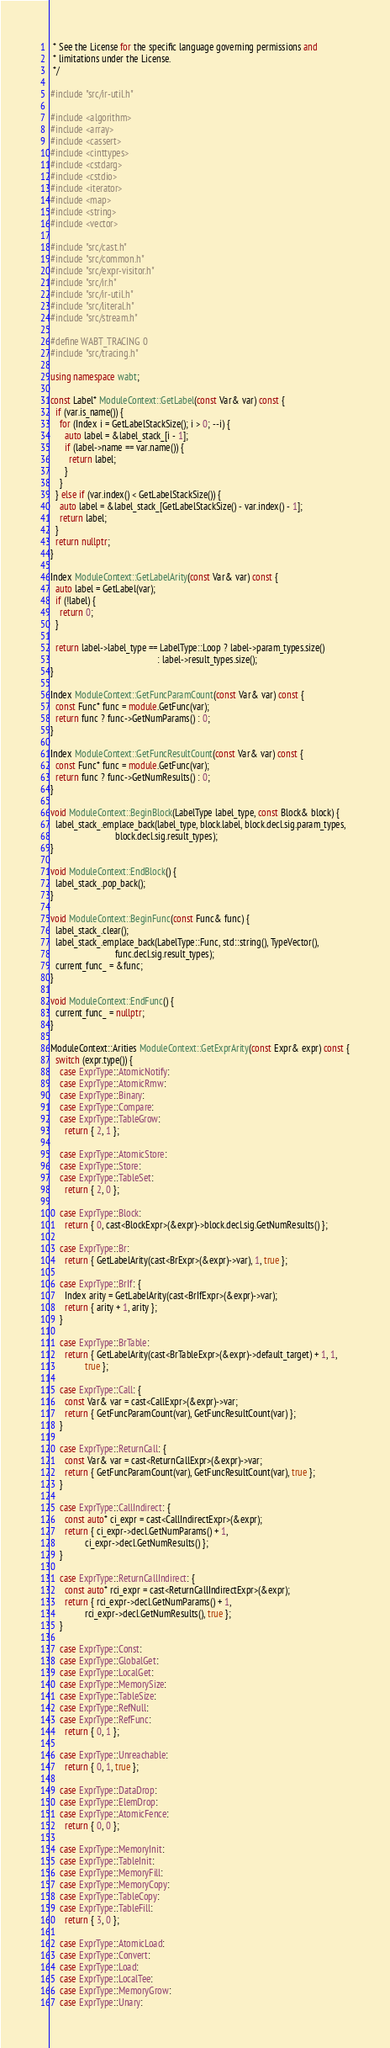Convert code to text. <code><loc_0><loc_0><loc_500><loc_500><_C++_> * See the License for the specific language governing permissions and
 * limitations under the License.
 */

#include "src/ir-util.h"

#include <algorithm>
#include <array>
#include <cassert>
#include <cinttypes>
#include <cstdarg>
#include <cstdio>
#include <iterator>
#include <map>
#include <string>
#include <vector>

#include "src/cast.h"
#include "src/common.h"
#include "src/expr-visitor.h"
#include "src/ir.h"
#include "src/ir-util.h"
#include "src/literal.h"
#include "src/stream.h"

#define WABT_TRACING 0
#include "src/tracing.h"

using namespace wabt;

const Label* ModuleContext::GetLabel(const Var& var) const {
  if (var.is_name()) {
    for (Index i = GetLabelStackSize(); i > 0; --i) {
      auto label = &label_stack_[i - 1];
      if (label->name == var.name()) {
        return label;
      }
    }
  } else if (var.index() < GetLabelStackSize()) {
    auto label = &label_stack_[GetLabelStackSize() - var.index() - 1];
    return label;
  }
  return nullptr;
}

Index ModuleContext::GetLabelArity(const Var& var) const {
  auto label = GetLabel(var);
  if (!label) {
    return 0;
  }

  return label->label_type == LabelType::Loop ? label->param_types.size()
                                              : label->result_types.size();
}

Index ModuleContext::GetFuncParamCount(const Var& var) const {
  const Func* func = module.GetFunc(var);
  return func ? func->GetNumParams() : 0;
}

Index ModuleContext::GetFuncResultCount(const Var& var) const {
  const Func* func = module.GetFunc(var);
  return func ? func->GetNumResults() : 0;
}

void ModuleContext::BeginBlock(LabelType label_type, const Block& block) {
  label_stack_.emplace_back(label_type, block.label, block.decl.sig.param_types,
                            block.decl.sig.result_types);
}

void ModuleContext::EndBlock() {
  label_stack_.pop_back();
}

void ModuleContext::BeginFunc(const Func& func) {
  label_stack_.clear();
  label_stack_.emplace_back(LabelType::Func, std::string(), TypeVector(),
                            func.decl.sig.result_types);
  current_func_ = &func;
}

void ModuleContext::EndFunc() {
  current_func_ = nullptr;
}

ModuleContext::Arities ModuleContext::GetExprArity(const Expr& expr) const {
  switch (expr.type()) {
    case ExprType::AtomicNotify:
    case ExprType::AtomicRmw:
    case ExprType::Binary:
    case ExprType::Compare:
    case ExprType::TableGrow:
      return { 2, 1 };

    case ExprType::AtomicStore:
    case ExprType::Store:
    case ExprType::TableSet:
      return { 2, 0 };

    case ExprType::Block:
      return { 0, cast<BlockExpr>(&expr)->block.decl.sig.GetNumResults() };

    case ExprType::Br:
      return { GetLabelArity(cast<BrExpr>(&expr)->var), 1, true };

    case ExprType::BrIf: {
      Index arity = GetLabelArity(cast<BrIfExpr>(&expr)->var);
      return { arity + 1, arity };
    }

    case ExprType::BrTable:
      return { GetLabelArity(cast<BrTableExpr>(&expr)->default_target) + 1, 1,
               true };

    case ExprType::Call: {
      const Var& var = cast<CallExpr>(&expr)->var;
      return { GetFuncParamCount(var), GetFuncResultCount(var) };
    }

    case ExprType::ReturnCall: {
      const Var& var = cast<ReturnCallExpr>(&expr)->var;
      return { GetFuncParamCount(var), GetFuncResultCount(var), true };
    }

    case ExprType::CallIndirect: {
      const auto* ci_expr = cast<CallIndirectExpr>(&expr);
      return { ci_expr->decl.GetNumParams() + 1,
               ci_expr->decl.GetNumResults() };
    }

    case ExprType::ReturnCallIndirect: {
      const auto* rci_expr = cast<ReturnCallIndirectExpr>(&expr);
      return { rci_expr->decl.GetNumParams() + 1,
               rci_expr->decl.GetNumResults(), true };
    }

    case ExprType::Const:
    case ExprType::GlobalGet:
    case ExprType::LocalGet:
    case ExprType::MemorySize:
    case ExprType::TableSize:
    case ExprType::RefNull:
    case ExprType::RefFunc:
      return { 0, 1 };

    case ExprType::Unreachable:
      return { 0, 1, true };

    case ExprType::DataDrop:
    case ExprType::ElemDrop:
    case ExprType::AtomicFence:
      return { 0, 0 };

    case ExprType::MemoryInit:
    case ExprType::TableInit:
    case ExprType::MemoryFill:
    case ExprType::MemoryCopy:
    case ExprType::TableCopy:
    case ExprType::TableFill:
      return { 3, 0 };

    case ExprType::AtomicLoad:
    case ExprType::Convert:
    case ExprType::Load:
    case ExprType::LocalTee:
    case ExprType::MemoryGrow:
    case ExprType::Unary:</code> 